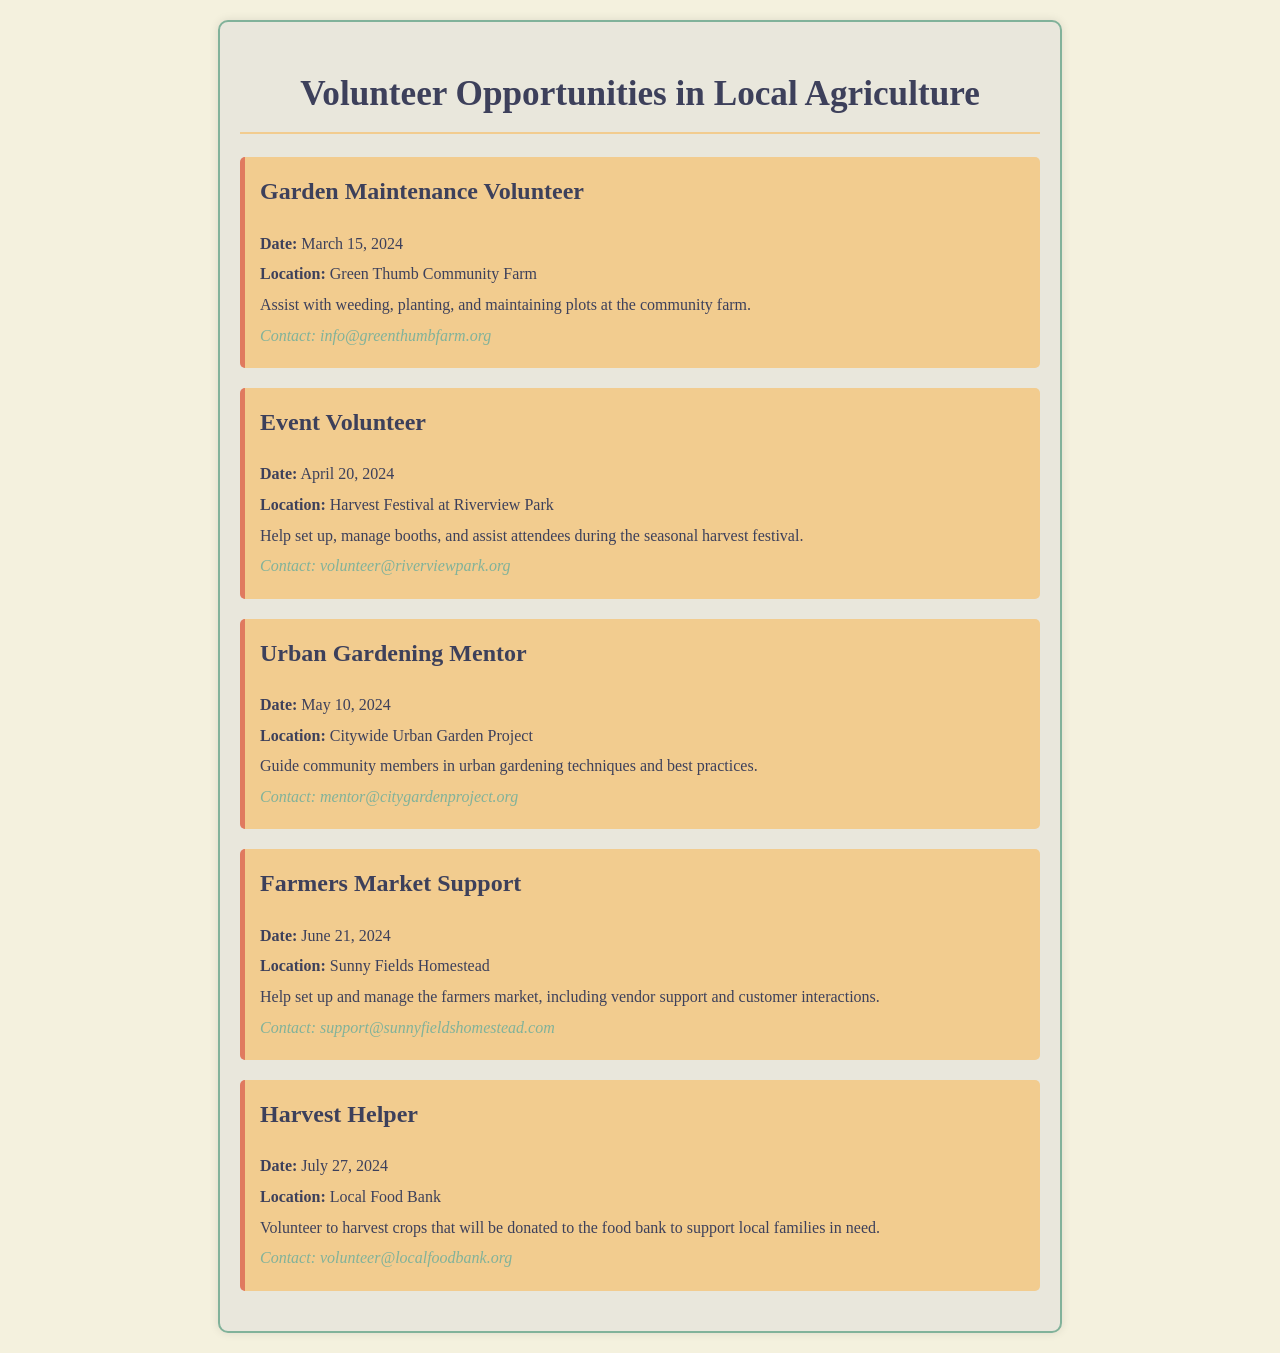What is the date of the Garden Maintenance Volunteer event? The date is found in the event details for Garden Maintenance Volunteer, which states March 15, 2024.
Answer: March 15, 2024 Where is the Harvest Festival taking place? The location is specified in the event details for the Harvest Festival at Riverview Park.
Answer: Riverview Park What role is available on June 21, 2024? The role is described in the details of the Farmers Market Support event scheduled for that date.
Answer: Farmers Market Support Who should be contacted for the Urban Gardening Mentor event? The contact information is provided for the Urban Gardening Mentor event, showing the email address for inquiries.
Answer: mentor@citygardenproject.org What is the main activity for the Harvest Helper role? The activity is explained in the description of the Harvest Helper event, indicating volunteering to harvest crops.
Answer: Harvest crops What is the earliest event listed in the document? The earliest event can be identified by looking at the dates provided in each event entry.
Answer: Garden Maintenance Volunteer Which organization is running the event on May 10, 2024? The organization can be determined from the event title and location for the Urban Gardening Mentor event.
Answer: Citywide Urban Garden Project What type of assistance is needed during the Harvest Festival? The type of assistance is mentioned in the description of tasks for the Event Volunteer at the Harvest Festival.
Answer: Set up and manage booths What is one of the tasks for the Farmers Market Support role? The tasks can be found in the details of the Farmers Market Support event, which lists some responsibilities.
Answer: Manage the farmers market 